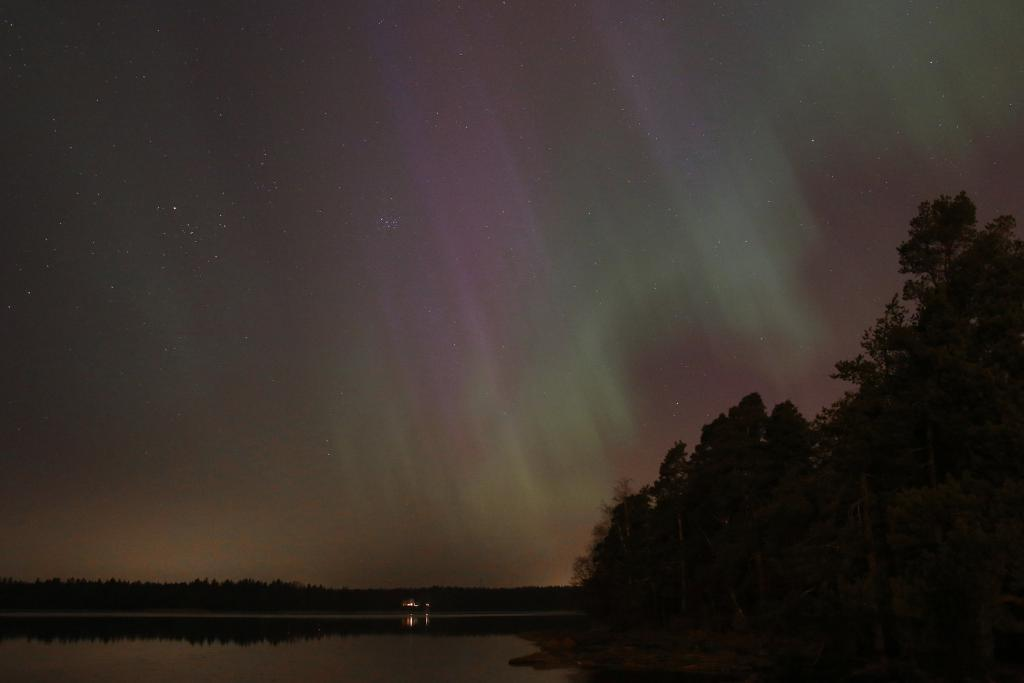What type of vegetation can be seen in the image? There are trees in the image. What natural element is visible in the image? There is water visible in the image. What part of the natural environment is visible in the image? The sky is visible in the image. What religion is being practiced by the trees in the image? There is no indication of any religious practice in the image, as it features trees, water, and the sky. 